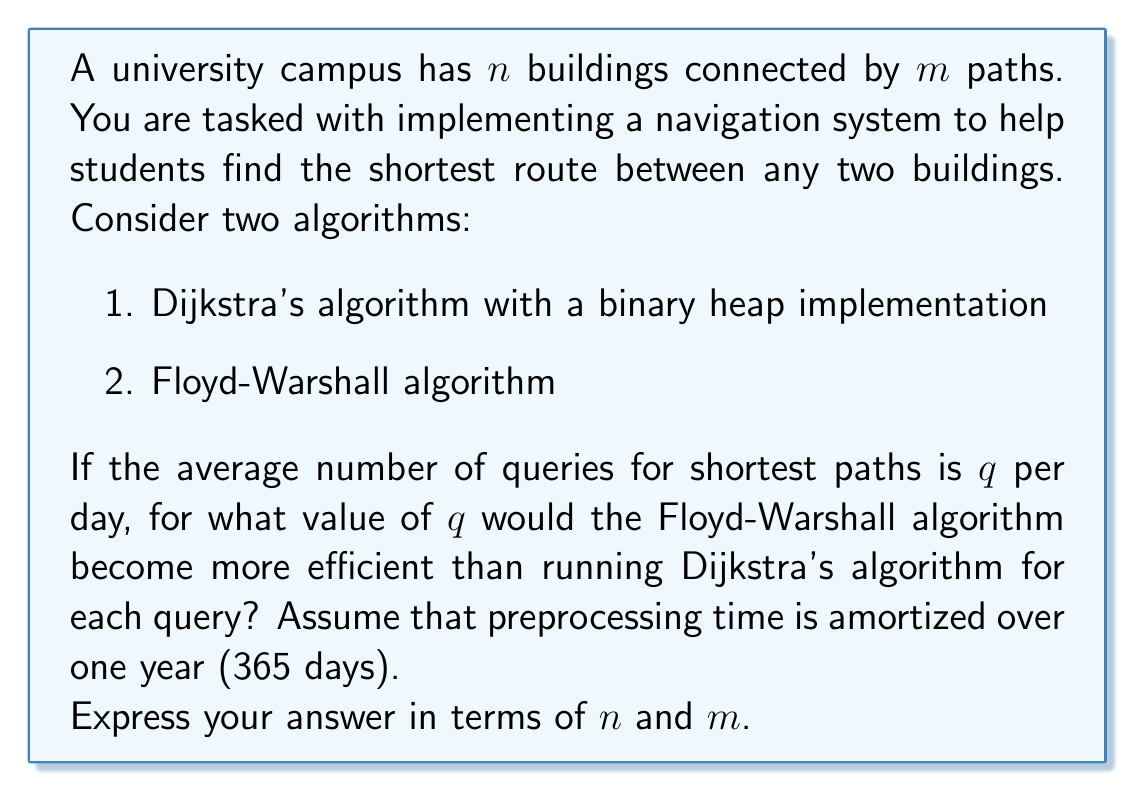Could you help me with this problem? Let's analyze the time complexities and compare the two algorithms:

1. Dijkstra's algorithm (with binary heap):
   - Time complexity: $O((m + n) \log n)$ per query
   - Total time for $q$ queries per day: $O(q(m + n) \log n)$

2. Floyd-Warshall algorithm:
   - Preprocessing time: $O(n^3)$
   - Query time: $O(1)$
   - Total time including preprocessing (amortized over a year): $O(n^3/365 + q)$

For Floyd-Warshall to be more efficient:

$$O(n^3/365 + q) < O(q(m + n) \log n)$$

Simplifying and focusing on the dominant terms:

$$n^3/365 + q < q(m + n) \log n$$

Solving for $q$:

$$q(m + n) \log n - q > n^3/365$$
$$q((m + n) \log n - 1) > n^3/365$$
$$q > \frac{n^3}{365((m + n) \log n - 1)}$$

The Floyd-Warshall algorithm becomes more efficient when $q$ exceeds this threshold.
Answer: $q > \frac{n^3}{365((m + n) \log n - 1)}$ 